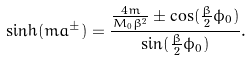Convert formula to latex. <formula><loc_0><loc_0><loc_500><loc_500>\sinh ( m a ^ { \pm } ) = \frac { \frac { 4 m } { M _ { 0 } \beta ^ { 2 } } \pm \cos ( \frac { \beta } { 2 } \phi _ { 0 } ) } { \sin ( \frac { \beta } { 2 } \phi _ { 0 } ) } .</formula> 